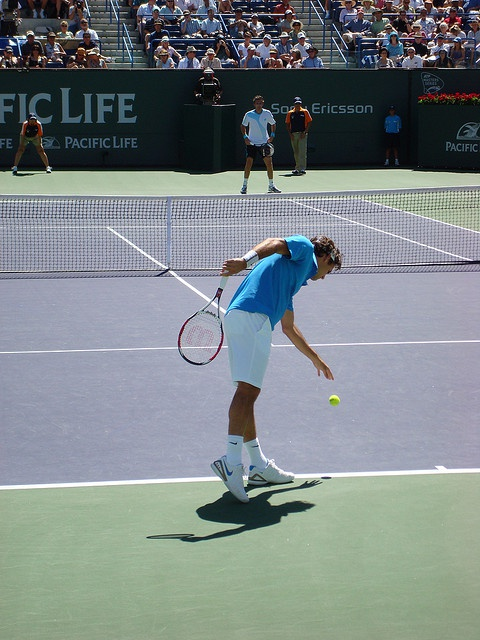Describe the objects in this image and their specific colors. I can see people in lavender, black, gray, maroon, and navy tones, people in lavender, darkgray, gray, maroon, and blue tones, tennis racket in lavender, darkgray, lightgray, and black tones, people in lavender, black, gray, and maroon tones, and people in lavender, black, maroon, and gray tones in this image. 